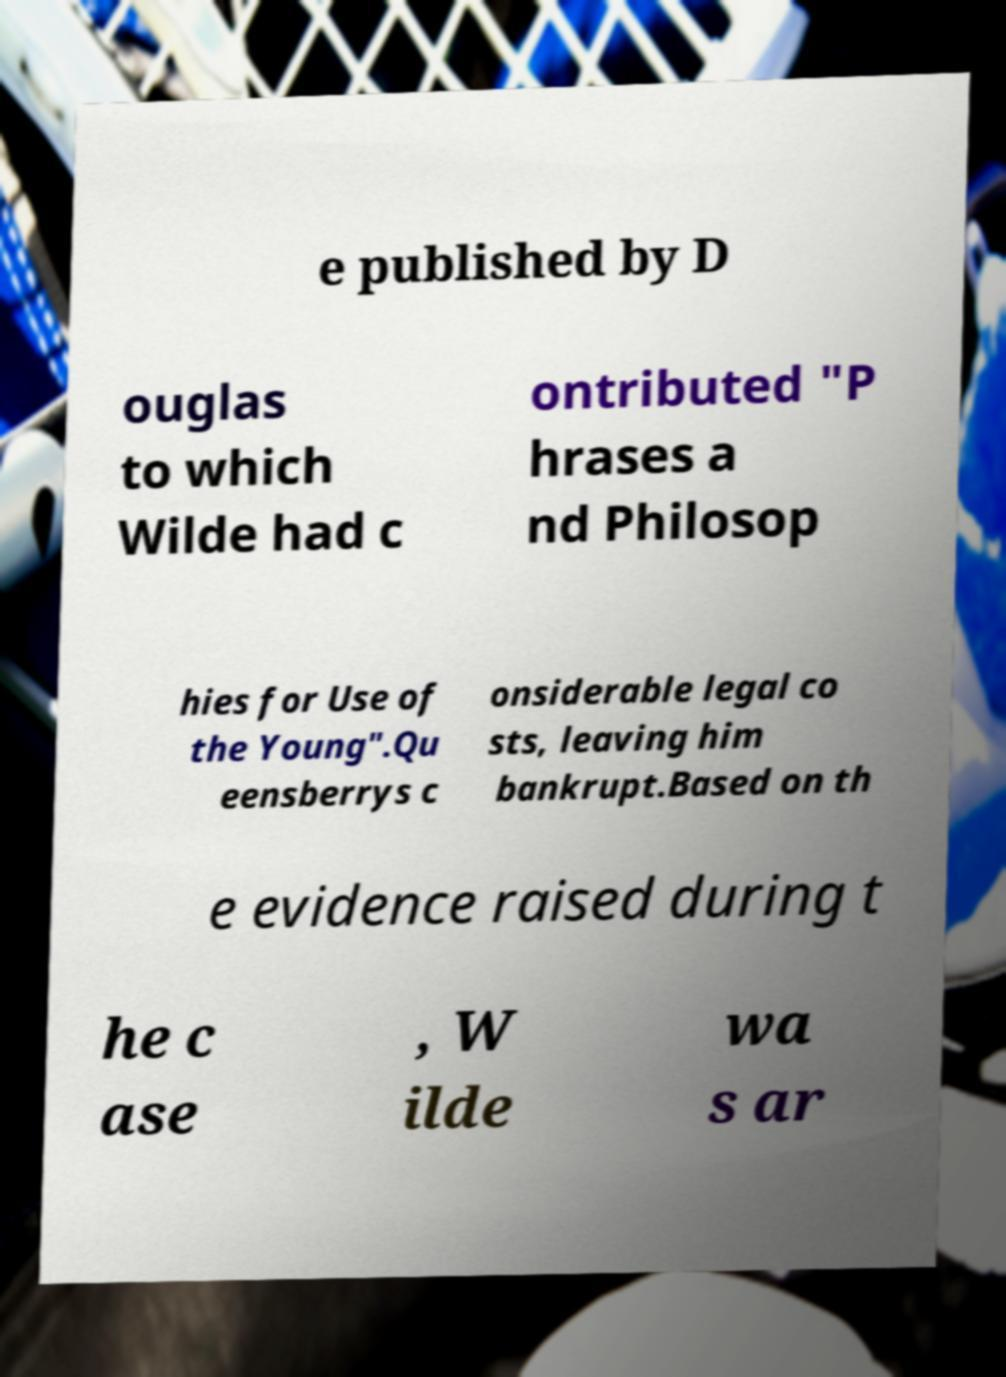What messages or text are displayed in this image? I need them in a readable, typed format. e published by D ouglas to which Wilde had c ontributed "P hrases a nd Philosop hies for Use of the Young".Qu eensberrys c onsiderable legal co sts, leaving him bankrupt.Based on th e evidence raised during t he c ase , W ilde wa s ar 